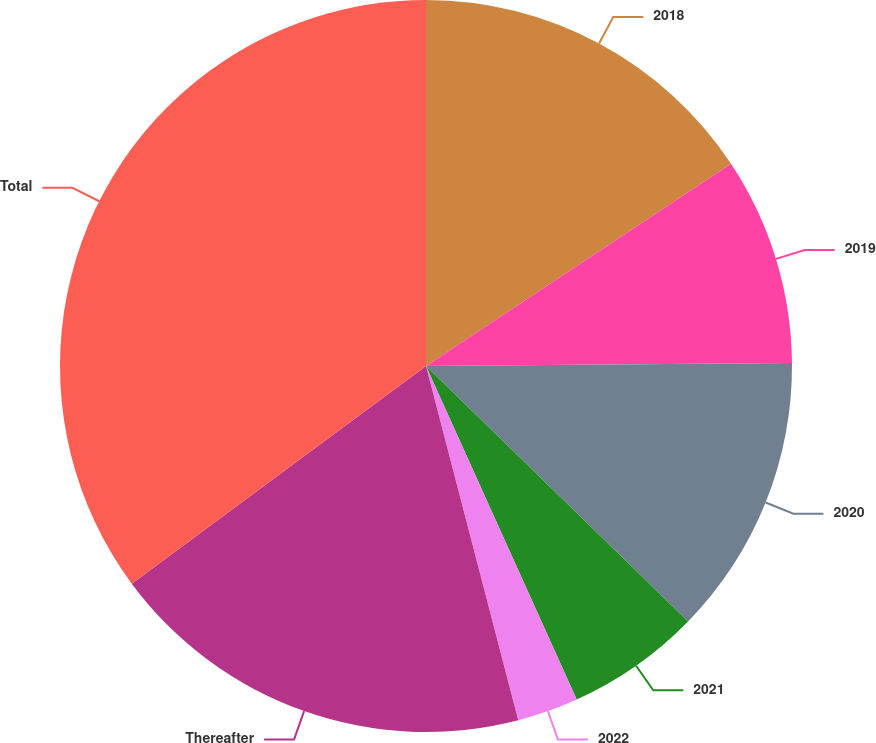Convert chart to OTSL. <chart><loc_0><loc_0><loc_500><loc_500><pie_chart><fcel>2018<fcel>2019<fcel>2020<fcel>2021<fcel>2022<fcel>Thereafter<fcel>Total<nl><fcel>15.68%<fcel>9.19%<fcel>12.43%<fcel>5.95%<fcel>2.7%<fcel>18.92%<fcel>35.14%<nl></chart> 